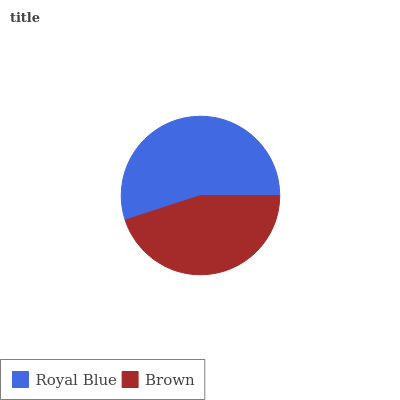Is Brown the minimum?
Answer yes or no. Yes. Is Royal Blue the maximum?
Answer yes or no. Yes. Is Brown the maximum?
Answer yes or no. No. Is Royal Blue greater than Brown?
Answer yes or no. Yes. Is Brown less than Royal Blue?
Answer yes or no. Yes. Is Brown greater than Royal Blue?
Answer yes or no. No. Is Royal Blue less than Brown?
Answer yes or no. No. Is Royal Blue the high median?
Answer yes or no. Yes. Is Brown the low median?
Answer yes or no. Yes. Is Brown the high median?
Answer yes or no. No. Is Royal Blue the low median?
Answer yes or no. No. 